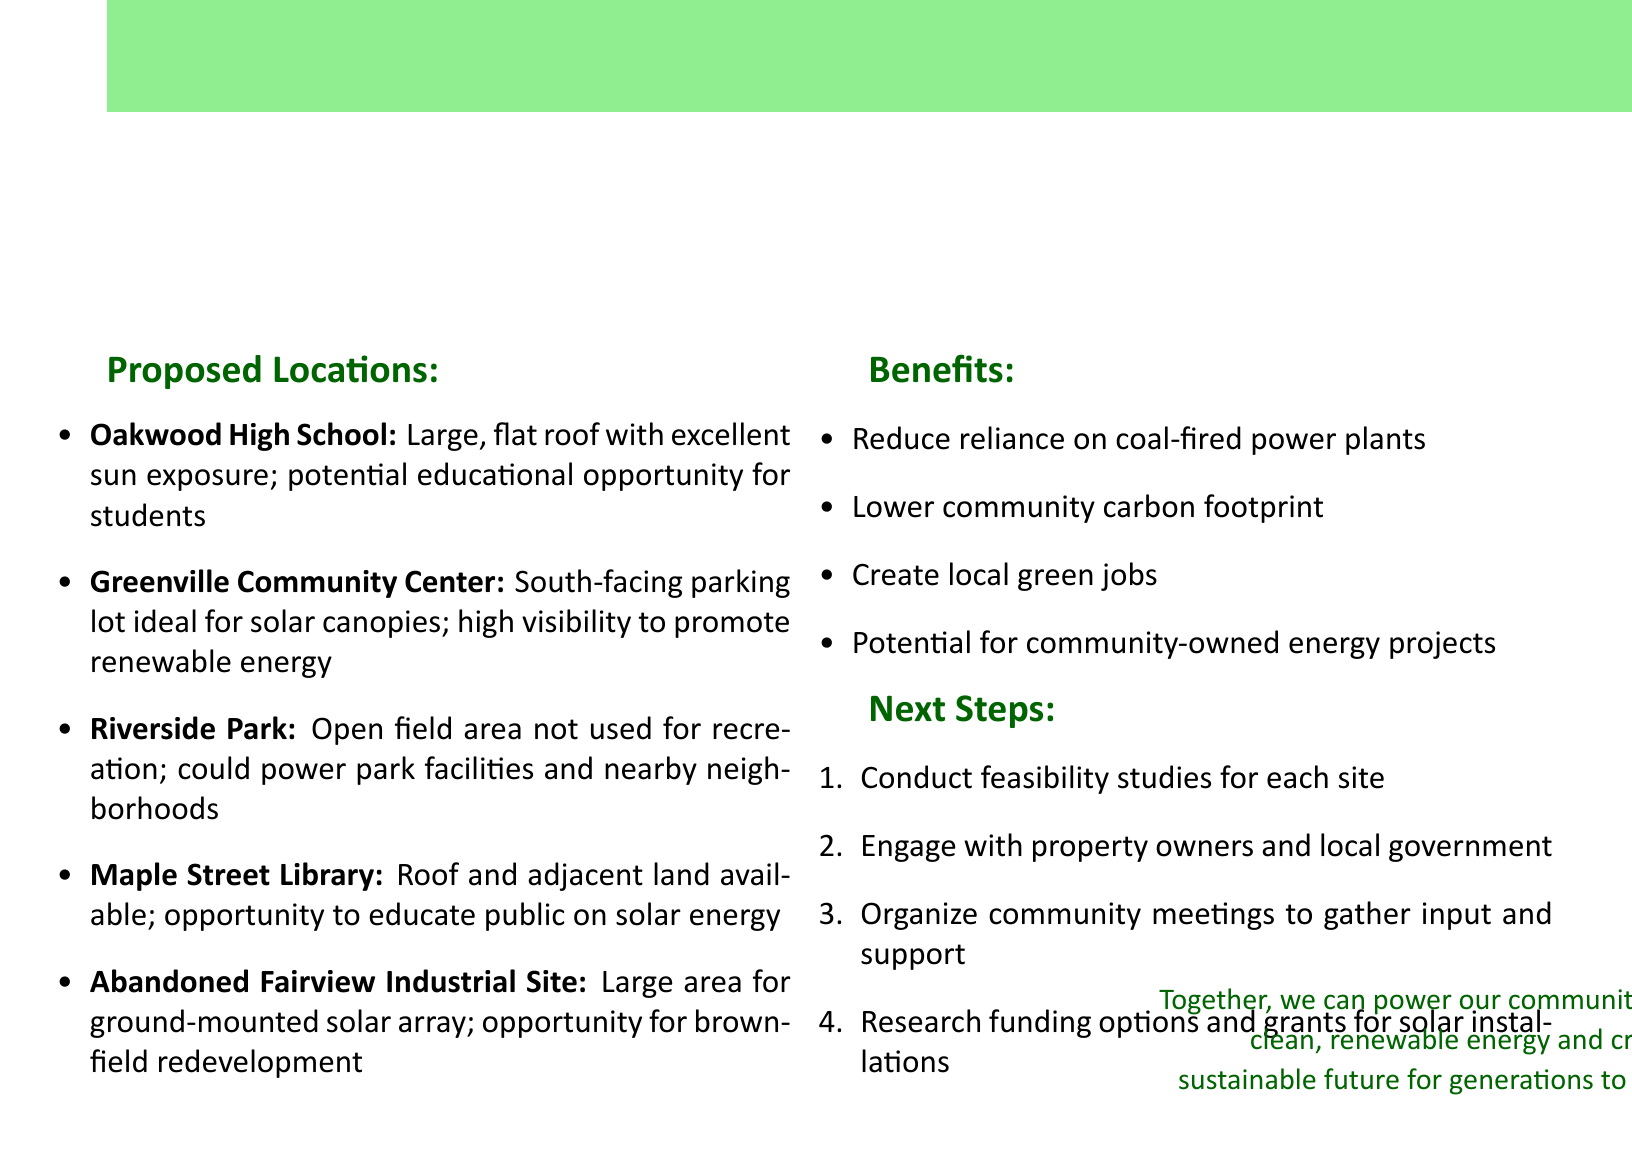what is the title of the document? The title is clearly stated at the beginning of the document.
Answer: Potential Solar Panel Installation Locations in Our Community how many locations are proposed for solar panel installation? The list of locations is provided, and counting them reveals the total.
Answer: 5 which location has a potential educational opportunity for students? The details mention an educational opportunity specifically associated with a certain location.
Answer: Oakwood High School what benefit is mentioned related to job creation? The benefits section outlines specific positive outcomes for the community, including job-related benefits.
Answer: Create local green jobs what is one of the next steps mentioned in the document? The next steps are listed sequentially, and any of them can be selected for an answer.
Answer: Conduct feasibility studies for each site which location is described as having high visibility to promote renewable energy? The details about visibility are specified for a particular location in the document.
Answer: Greenville Community Center what type of solar installation is suggested for Riverside Park? The details for Riverside Park provide specifics on the type of installation proposed.
Answer: Power park facilities and nearby neighborhoods what opportunity is associated with the Abandoned Fairview Industrial Site? The explanation regarding the site mentions a specific opportunity in the context of redevelopment.
Answer: Opportunity for brownfield redevelopment 